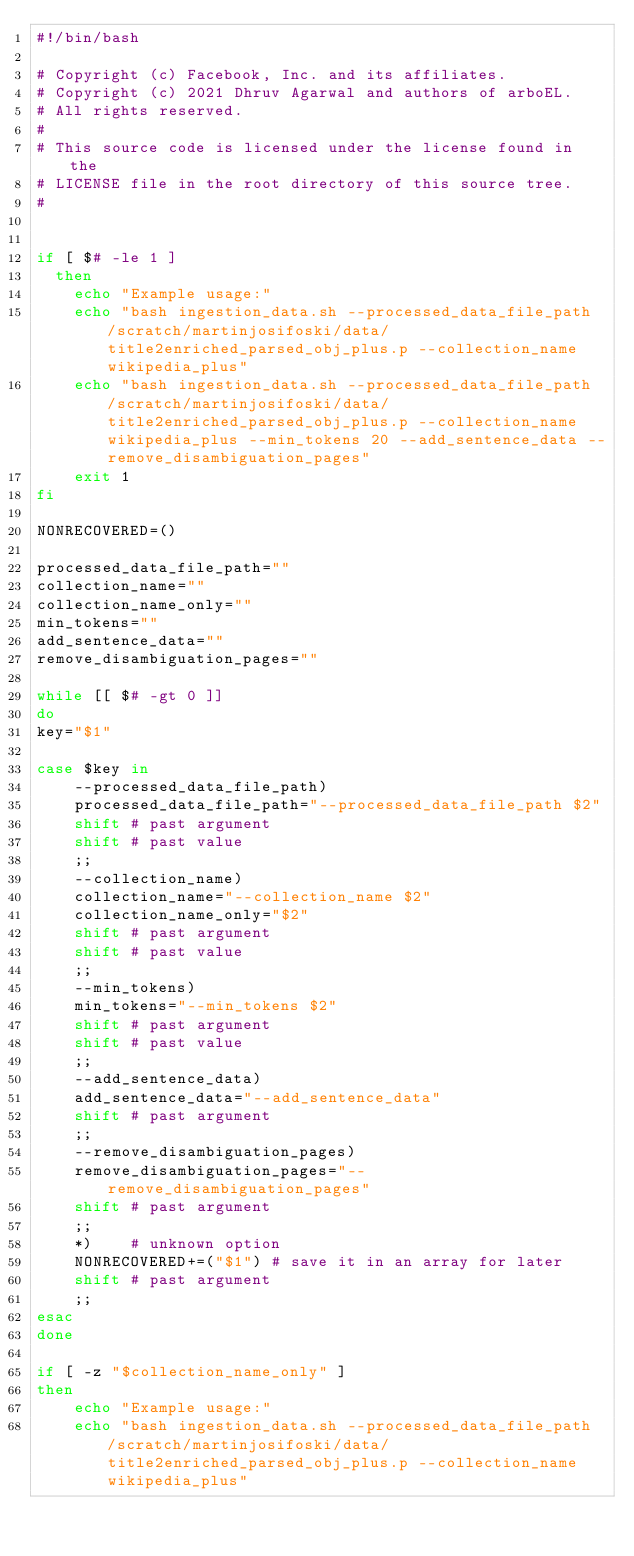Convert code to text. <code><loc_0><loc_0><loc_500><loc_500><_Bash_>#!/bin/bash

# Copyright (c) Facebook, Inc. and its affiliates.
# Copyright (c) 2021 Dhruv Agarwal and authors of arboEL.
# All rights reserved.
#
# This source code is licensed under the license found in the
# LICENSE file in the root directory of this source tree.
#


if [ $# -le 1 ]
  then
    echo "Example usage:"
    echo "bash ingestion_data.sh --processed_data_file_path /scratch/martinjosifoski/data/title2enriched_parsed_obj_plus.p --collection_name wikipedia_plus"
    echo "bash ingestion_data.sh --processed_data_file_path /scratch/martinjosifoski/data/title2enriched_parsed_obj_plus.p --collection_name wikipedia_plus --min_tokens 20 --add_sentence_data --remove_disambiguation_pages"
    exit 1
fi

NONRECOVERED=()

processed_data_file_path=""
collection_name=""
collection_name_only=""
min_tokens=""
add_sentence_data=""
remove_disambiguation_pages=""

while [[ $# -gt 0 ]]
do
key="$1"

case $key in
    --processed_data_file_path)
    processed_data_file_path="--processed_data_file_path $2"
    shift # past argument
    shift # past value
    ;;
    --collection_name)
    collection_name="--collection_name $2"
    collection_name_only="$2"
    shift # past argument
    shift # past value
    ;;
    --min_tokens)
    min_tokens="--min_tokens $2"
    shift # past argument
    shift # past value
    ;;
    --add_sentence_data)
    add_sentence_data="--add_sentence_data"
    shift # past argument
    ;;
    --remove_disambiguation_pages)
    remove_disambiguation_pages="--remove_disambiguation_pages"
    shift # past argument
    ;;
    *)    # unknown option
    NONRECOVERED+=("$1") # save it in an array for later
    shift # past argument
    ;;
esac
done

if [ -z "$collection_name_only" ]
then
    echo "Example usage:"
    echo "bash ingestion_data.sh --processed_data_file_path /scratch/martinjosifoski/data/title2enriched_parsed_obj_plus.p --collection_name wikipedia_plus"</code> 